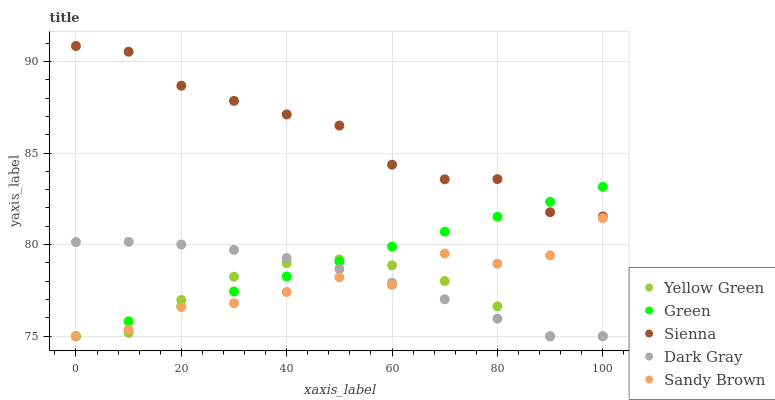Does Yellow Green have the minimum area under the curve?
Answer yes or no. Yes. Does Sienna have the maximum area under the curve?
Answer yes or no. Yes. Does Dark Gray have the minimum area under the curve?
Answer yes or no. No. Does Dark Gray have the maximum area under the curve?
Answer yes or no. No. Is Green the smoothest?
Answer yes or no. Yes. Is Sandy Brown the roughest?
Answer yes or no. Yes. Is Dark Gray the smoothest?
Answer yes or no. No. Is Dark Gray the roughest?
Answer yes or no. No. Does Dark Gray have the lowest value?
Answer yes or no. Yes. Does Sienna have the highest value?
Answer yes or no. Yes. Does Dark Gray have the highest value?
Answer yes or no. No. Is Sandy Brown less than Sienna?
Answer yes or no. Yes. Is Sienna greater than Yellow Green?
Answer yes or no. Yes. Does Sandy Brown intersect Dark Gray?
Answer yes or no. Yes. Is Sandy Brown less than Dark Gray?
Answer yes or no. No. Is Sandy Brown greater than Dark Gray?
Answer yes or no. No. Does Sandy Brown intersect Sienna?
Answer yes or no. No. 